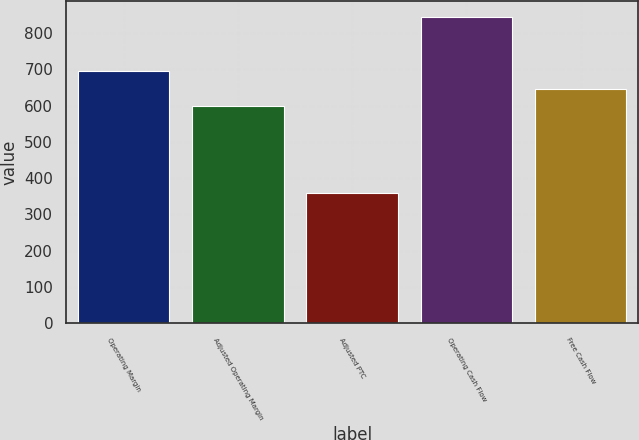Convert chart. <chart><loc_0><loc_0><loc_500><loc_500><bar_chart><fcel>Operating Margin<fcel>Adjusted Operating Margin<fcel>Adjusted PTC<fcel>Operating Cash Flow<fcel>Free Cash Flow<nl><fcel>695<fcel>598<fcel>360<fcel>845<fcel>646.5<nl></chart> 